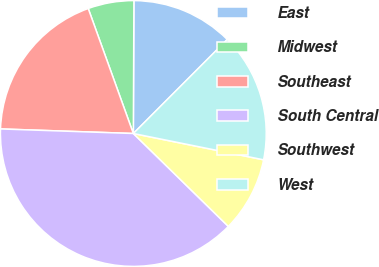Convert chart to OTSL. <chart><loc_0><loc_0><loc_500><loc_500><pie_chart><fcel>East<fcel>Midwest<fcel>Southeast<fcel>South Central<fcel>Southwest<fcel>West<nl><fcel>12.42%<fcel>5.58%<fcel>18.94%<fcel>38.22%<fcel>9.15%<fcel>15.68%<nl></chart> 